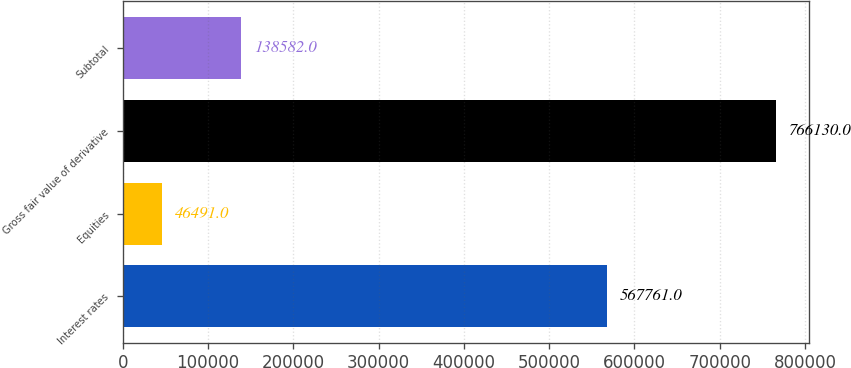Convert chart to OTSL. <chart><loc_0><loc_0><loc_500><loc_500><bar_chart><fcel>Interest rates<fcel>Equities<fcel>Gross fair value of derivative<fcel>Subtotal<nl><fcel>567761<fcel>46491<fcel>766130<fcel>138582<nl></chart> 